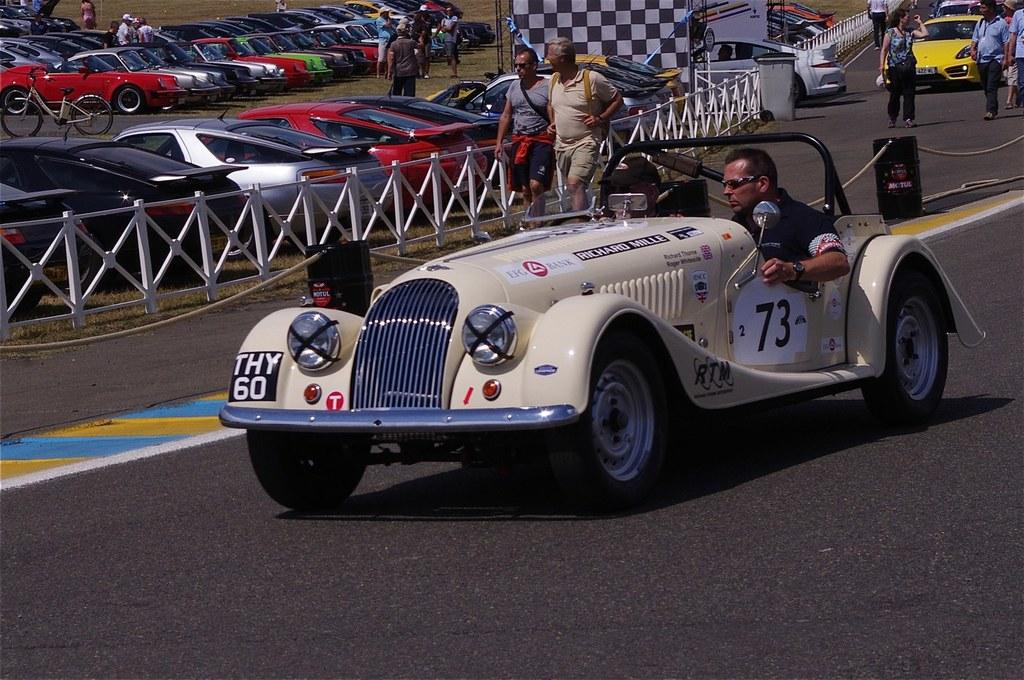What can be seen in the image related to vehicles? There are cars parked in the image. What activity involving a vehicle is taking place in the image? A man is driving on the road in the image. What type of activity involving people can be seen in the image? Two persons are walking on the road in the image. What type of grain is being harvested in the image? There is no grain or harvesting activity present in the image. What design can be seen on the road in the image? The image does not focus on the design of the road; it shows cars, a driving man, and two persons walking. 